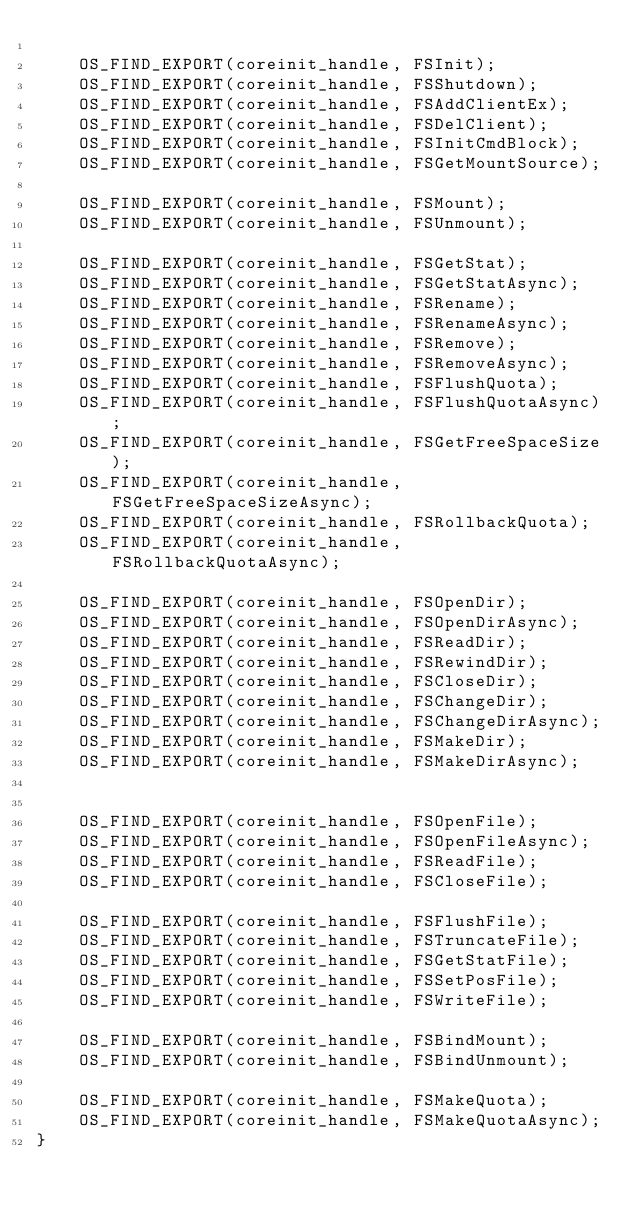Convert code to text. <code><loc_0><loc_0><loc_500><loc_500><_C_>
    OS_FIND_EXPORT(coreinit_handle, FSInit);
    OS_FIND_EXPORT(coreinit_handle, FSShutdown);
    OS_FIND_EXPORT(coreinit_handle, FSAddClientEx);
    OS_FIND_EXPORT(coreinit_handle, FSDelClient);
    OS_FIND_EXPORT(coreinit_handle, FSInitCmdBlock);
    OS_FIND_EXPORT(coreinit_handle, FSGetMountSource);

    OS_FIND_EXPORT(coreinit_handle, FSMount);
    OS_FIND_EXPORT(coreinit_handle, FSUnmount);

    OS_FIND_EXPORT(coreinit_handle, FSGetStat);
    OS_FIND_EXPORT(coreinit_handle, FSGetStatAsync);
    OS_FIND_EXPORT(coreinit_handle, FSRename);
    OS_FIND_EXPORT(coreinit_handle, FSRenameAsync);
    OS_FIND_EXPORT(coreinit_handle, FSRemove);
    OS_FIND_EXPORT(coreinit_handle, FSRemoveAsync);
    OS_FIND_EXPORT(coreinit_handle, FSFlushQuota);
    OS_FIND_EXPORT(coreinit_handle, FSFlushQuotaAsync);
    OS_FIND_EXPORT(coreinit_handle, FSGetFreeSpaceSize);
    OS_FIND_EXPORT(coreinit_handle, FSGetFreeSpaceSizeAsync);
    OS_FIND_EXPORT(coreinit_handle, FSRollbackQuota);
    OS_FIND_EXPORT(coreinit_handle, FSRollbackQuotaAsync);

    OS_FIND_EXPORT(coreinit_handle, FSOpenDir);
    OS_FIND_EXPORT(coreinit_handle, FSOpenDirAsync);
    OS_FIND_EXPORT(coreinit_handle, FSReadDir);
    OS_FIND_EXPORT(coreinit_handle, FSRewindDir);
    OS_FIND_EXPORT(coreinit_handle, FSCloseDir);
    OS_FIND_EXPORT(coreinit_handle, FSChangeDir);
    OS_FIND_EXPORT(coreinit_handle, FSChangeDirAsync);
    OS_FIND_EXPORT(coreinit_handle, FSMakeDir);
    OS_FIND_EXPORT(coreinit_handle, FSMakeDirAsync);


    OS_FIND_EXPORT(coreinit_handle, FSOpenFile);
    OS_FIND_EXPORT(coreinit_handle, FSOpenFileAsync);
    OS_FIND_EXPORT(coreinit_handle, FSReadFile);
    OS_FIND_EXPORT(coreinit_handle, FSCloseFile);

    OS_FIND_EXPORT(coreinit_handle, FSFlushFile);
    OS_FIND_EXPORT(coreinit_handle, FSTruncateFile);
    OS_FIND_EXPORT(coreinit_handle, FSGetStatFile);
    OS_FIND_EXPORT(coreinit_handle, FSSetPosFile);
    OS_FIND_EXPORT(coreinit_handle, FSWriteFile);

    OS_FIND_EXPORT(coreinit_handle, FSBindMount);
    OS_FIND_EXPORT(coreinit_handle, FSBindUnmount);

    OS_FIND_EXPORT(coreinit_handle, FSMakeQuota);
    OS_FIND_EXPORT(coreinit_handle, FSMakeQuotaAsync);
}
</code> 